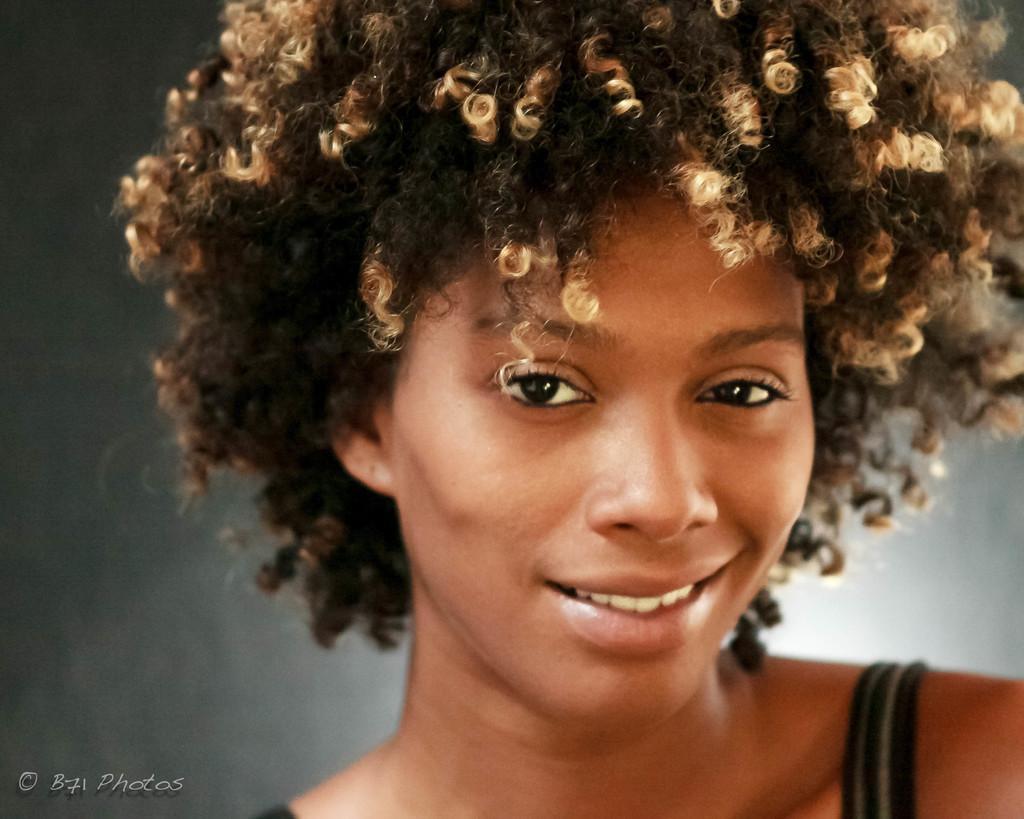Can you describe this image briefly? In this image, we can see a person. There is a text in the bottom left of the image. 